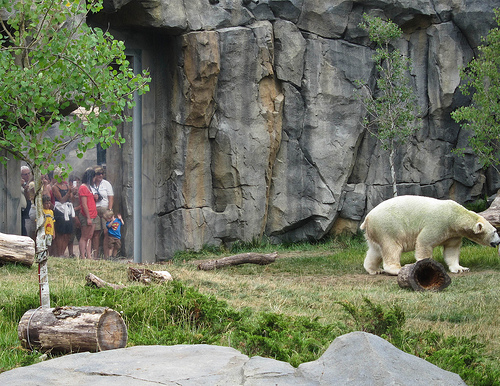<image>
Is there a bear on the rock? No. The bear is not positioned on the rock. They may be near each other, but the bear is not supported by or resting on top of the rock. 